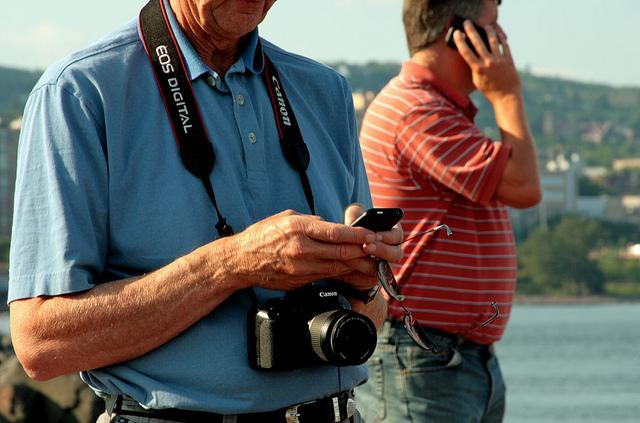What does the man do with the object around his neck? take photos 